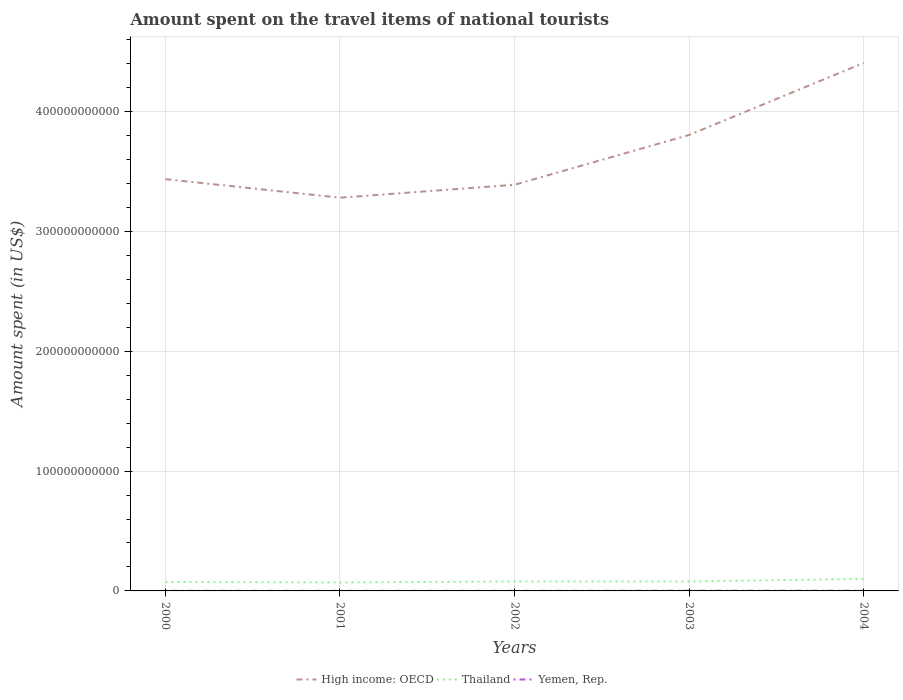How many different coloured lines are there?
Provide a short and direct response. 3. Is the number of lines equal to the number of legend labels?
Offer a terse response. Yes. Across all years, what is the maximum amount spent on the travel items of national tourists in Thailand?
Offer a terse response. 7.08e+09. What is the total amount spent on the travel items of national tourists in High income: OECD in the graph?
Your answer should be compact. -1.08e+1. What is the difference between the highest and the second highest amount spent on the travel items of national tourists in Thailand?
Your answer should be very brief. 2.97e+09. What is the difference between the highest and the lowest amount spent on the travel items of national tourists in Yemen, Rep.?
Keep it short and to the point. 2. Is the amount spent on the travel items of national tourists in Thailand strictly greater than the amount spent on the travel items of national tourists in Yemen, Rep. over the years?
Offer a terse response. No. How many years are there in the graph?
Keep it short and to the point. 5. What is the difference between two consecutive major ticks on the Y-axis?
Provide a short and direct response. 1.00e+11. Are the values on the major ticks of Y-axis written in scientific E-notation?
Your answer should be compact. No. Does the graph contain grids?
Your answer should be compact. Yes. Where does the legend appear in the graph?
Ensure brevity in your answer.  Bottom center. How are the legend labels stacked?
Ensure brevity in your answer.  Horizontal. What is the title of the graph?
Make the answer very short. Amount spent on the travel items of national tourists. What is the label or title of the X-axis?
Offer a terse response. Years. What is the label or title of the Y-axis?
Give a very brief answer. Amount spent (in US$). What is the Amount spent (in US$) in High income: OECD in 2000?
Provide a short and direct response. 3.44e+11. What is the Amount spent (in US$) of Thailand in 2000?
Your response must be concise. 7.48e+09. What is the Amount spent (in US$) in Yemen, Rep. in 2000?
Offer a terse response. 7.30e+07. What is the Amount spent (in US$) of High income: OECD in 2001?
Offer a very short reply. 3.28e+11. What is the Amount spent (in US$) in Thailand in 2001?
Make the answer very short. 7.08e+09. What is the Amount spent (in US$) of Yemen, Rep. in 2001?
Provide a short and direct response. 3.80e+07. What is the Amount spent (in US$) of High income: OECD in 2002?
Provide a short and direct response. 3.39e+11. What is the Amount spent (in US$) in Thailand in 2002?
Offer a very short reply. 7.90e+09. What is the Amount spent (in US$) of Yemen, Rep. in 2002?
Offer a terse response. 3.80e+07. What is the Amount spent (in US$) in High income: OECD in 2003?
Offer a terse response. 3.80e+11. What is the Amount spent (in US$) in Thailand in 2003?
Keep it short and to the point. 7.86e+09. What is the Amount spent (in US$) in Yemen, Rep. in 2003?
Ensure brevity in your answer.  1.39e+08. What is the Amount spent (in US$) of High income: OECD in 2004?
Offer a very short reply. 4.40e+11. What is the Amount spent (in US$) in Thailand in 2004?
Offer a terse response. 1.00e+1. What is the Amount spent (in US$) in Yemen, Rep. in 2004?
Provide a short and direct response. 1.39e+08. Across all years, what is the maximum Amount spent (in US$) of High income: OECD?
Keep it short and to the point. 4.40e+11. Across all years, what is the maximum Amount spent (in US$) in Thailand?
Give a very brief answer. 1.00e+1. Across all years, what is the maximum Amount spent (in US$) of Yemen, Rep.?
Offer a very short reply. 1.39e+08. Across all years, what is the minimum Amount spent (in US$) in High income: OECD?
Give a very brief answer. 3.28e+11. Across all years, what is the minimum Amount spent (in US$) of Thailand?
Your answer should be compact. 7.08e+09. Across all years, what is the minimum Amount spent (in US$) of Yemen, Rep.?
Ensure brevity in your answer.  3.80e+07. What is the total Amount spent (in US$) in High income: OECD in the graph?
Give a very brief answer. 1.83e+12. What is the total Amount spent (in US$) in Thailand in the graph?
Offer a very short reply. 4.04e+1. What is the total Amount spent (in US$) in Yemen, Rep. in the graph?
Keep it short and to the point. 4.27e+08. What is the difference between the Amount spent (in US$) in High income: OECD in 2000 and that in 2001?
Your answer should be very brief. 1.55e+1. What is the difference between the Amount spent (in US$) of Thailand in 2000 and that in 2001?
Give a very brief answer. 4.08e+08. What is the difference between the Amount spent (in US$) in Yemen, Rep. in 2000 and that in 2001?
Keep it short and to the point. 3.50e+07. What is the difference between the Amount spent (in US$) in High income: OECD in 2000 and that in 2002?
Make the answer very short. 4.70e+09. What is the difference between the Amount spent (in US$) of Thailand in 2000 and that in 2002?
Ensure brevity in your answer.  -4.18e+08. What is the difference between the Amount spent (in US$) in Yemen, Rep. in 2000 and that in 2002?
Provide a succinct answer. 3.50e+07. What is the difference between the Amount spent (in US$) of High income: OECD in 2000 and that in 2003?
Your response must be concise. -3.68e+1. What is the difference between the Amount spent (in US$) in Thailand in 2000 and that in 2003?
Your answer should be very brief. -3.73e+08. What is the difference between the Amount spent (in US$) of Yemen, Rep. in 2000 and that in 2003?
Provide a short and direct response. -6.60e+07. What is the difference between the Amount spent (in US$) of High income: OECD in 2000 and that in 2004?
Offer a very short reply. -9.69e+1. What is the difference between the Amount spent (in US$) of Thailand in 2000 and that in 2004?
Give a very brief answer. -2.56e+09. What is the difference between the Amount spent (in US$) of Yemen, Rep. in 2000 and that in 2004?
Offer a terse response. -6.60e+07. What is the difference between the Amount spent (in US$) of High income: OECD in 2001 and that in 2002?
Ensure brevity in your answer.  -1.08e+1. What is the difference between the Amount spent (in US$) in Thailand in 2001 and that in 2002?
Provide a succinct answer. -8.26e+08. What is the difference between the Amount spent (in US$) of Yemen, Rep. in 2001 and that in 2002?
Offer a very short reply. 0. What is the difference between the Amount spent (in US$) of High income: OECD in 2001 and that in 2003?
Provide a succinct answer. -5.23e+1. What is the difference between the Amount spent (in US$) of Thailand in 2001 and that in 2003?
Make the answer very short. -7.81e+08. What is the difference between the Amount spent (in US$) in Yemen, Rep. in 2001 and that in 2003?
Your answer should be compact. -1.01e+08. What is the difference between the Amount spent (in US$) of High income: OECD in 2001 and that in 2004?
Ensure brevity in your answer.  -1.12e+11. What is the difference between the Amount spent (in US$) of Thailand in 2001 and that in 2004?
Keep it short and to the point. -2.97e+09. What is the difference between the Amount spent (in US$) in Yemen, Rep. in 2001 and that in 2004?
Give a very brief answer. -1.01e+08. What is the difference between the Amount spent (in US$) of High income: OECD in 2002 and that in 2003?
Offer a very short reply. -4.15e+1. What is the difference between the Amount spent (in US$) of Thailand in 2002 and that in 2003?
Give a very brief answer. 4.50e+07. What is the difference between the Amount spent (in US$) of Yemen, Rep. in 2002 and that in 2003?
Provide a short and direct response. -1.01e+08. What is the difference between the Amount spent (in US$) of High income: OECD in 2002 and that in 2004?
Offer a terse response. -1.02e+11. What is the difference between the Amount spent (in US$) in Thailand in 2002 and that in 2004?
Offer a very short reply. -2.14e+09. What is the difference between the Amount spent (in US$) in Yemen, Rep. in 2002 and that in 2004?
Make the answer very short. -1.01e+08. What is the difference between the Amount spent (in US$) in High income: OECD in 2003 and that in 2004?
Provide a short and direct response. -6.01e+1. What is the difference between the Amount spent (in US$) in Thailand in 2003 and that in 2004?
Your answer should be very brief. -2.19e+09. What is the difference between the Amount spent (in US$) in High income: OECD in 2000 and the Amount spent (in US$) in Thailand in 2001?
Keep it short and to the point. 3.36e+11. What is the difference between the Amount spent (in US$) of High income: OECD in 2000 and the Amount spent (in US$) of Yemen, Rep. in 2001?
Your answer should be very brief. 3.43e+11. What is the difference between the Amount spent (in US$) in Thailand in 2000 and the Amount spent (in US$) in Yemen, Rep. in 2001?
Your answer should be very brief. 7.44e+09. What is the difference between the Amount spent (in US$) of High income: OECD in 2000 and the Amount spent (in US$) of Thailand in 2002?
Provide a short and direct response. 3.36e+11. What is the difference between the Amount spent (in US$) in High income: OECD in 2000 and the Amount spent (in US$) in Yemen, Rep. in 2002?
Ensure brevity in your answer.  3.43e+11. What is the difference between the Amount spent (in US$) in Thailand in 2000 and the Amount spent (in US$) in Yemen, Rep. in 2002?
Offer a terse response. 7.44e+09. What is the difference between the Amount spent (in US$) of High income: OECD in 2000 and the Amount spent (in US$) of Thailand in 2003?
Give a very brief answer. 3.36e+11. What is the difference between the Amount spent (in US$) of High income: OECD in 2000 and the Amount spent (in US$) of Yemen, Rep. in 2003?
Your response must be concise. 3.43e+11. What is the difference between the Amount spent (in US$) in Thailand in 2000 and the Amount spent (in US$) in Yemen, Rep. in 2003?
Your answer should be compact. 7.34e+09. What is the difference between the Amount spent (in US$) of High income: OECD in 2000 and the Amount spent (in US$) of Thailand in 2004?
Ensure brevity in your answer.  3.33e+11. What is the difference between the Amount spent (in US$) of High income: OECD in 2000 and the Amount spent (in US$) of Yemen, Rep. in 2004?
Provide a short and direct response. 3.43e+11. What is the difference between the Amount spent (in US$) of Thailand in 2000 and the Amount spent (in US$) of Yemen, Rep. in 2004?
Keep it short and to the point. 7.34e+09. What is the difference between the Amount spent (in US$) of High income: OECD in 2001 and the Amount spent (in US$) of Thailand in 2002?
Ensure brevity in your answer.  3.20e+11. What is the difference between the Amount spent (in US$) of High income: OECD in 2001 and the Amount spent (in US$) of Yemen, Rep. in 2002?
Make the answer very short. 3.28e+11. What is the difference between the Amount spent (in US$) of Thailand in 2001 and the Amount spent (in US$) of Yemen, Rep. in 2002?
Give a very brief answer. 7.04e+09. What is the difference between the Amount spent (in US$) in High income: OECD in 2001 and the Amount spent (in US$) in Thailand in 2003?
Provide a succinct answer. 3.20e+11. What is the difference between the Amount spent (in US$) in High income: OECD in 2001 and the Amount spent (in US$) in Yemen, Rep. in 2003?
Offer a very short reply. 3.28e+11. What is the difference between the Amount spent (in US$) of Thailand in 2001 and the Amount spent (in US$) of Yemen, Rep. in 2003?
Your answer should be compact. 6.94e+09. What is the difference between the Amount spent (in US$) in High income: OECD in 2001 and the Amount spent (in US$) in Thailand in 2004?
Give a very brief answer. 3.18e+11. What is the difference between the Amount spent (in US$) of High income: OECD in 2001 and the Amount spent (in US$) of Yemen, Rep. in 2004?
Ensure brevity in your answer.  3.28e+11. What is the difference between the Amount spent (in US$) in Thailand in 2001 and the Amount spent (in US$) in Yemen, Rep. in 2004?
Offer a terse response. 6.94e+09. What is the difference between the Amount spent (in US$) of High income: OECD in 2002 and the Amount spent (in US$) of Thailand in 2003?
Offer a terse response. 3.31e+11. What is the difference between the Amount spent (in US$) in High income: OECD in 2002 and the Amount spent (in US$) in Yemen, Rep. in 2003?
Give a very brief answer. 3.39e+11. What is the difference between the Amount spent (in US$) of Thailand in 2002 and the Amount spent (in US$) of Yemen, Rep. in 2003?
Offer a very short reply. 7.76e+09. What is the difference between the Amount spent (in US$) in High income: OECD in 2002 and the Amount spent (in US$) in Thailand in 2004?
Keep it short and to the point. 3.29e+11. What is the difference between the Amount spent (in US$) of High income: OECD in 2002 and the Amount spent (in US$) of Yemen, Rep. in 2004?
Your response must be concise. 3.39e+11. What is the difference between the Amount spent (in US$) in Thailand in 2002 and the Amount spent (in US$) in Yemen, Rep. in 2004?
Keep it short and to the point. 7.76e+09. What is the difference between the Amount spent (in US$) of High income: OECD in 2003 and the Amount spent (in US$) of Thailand in 2004?
Ensure brevity in your answer.  3.70e+11. What is the difference between the Amount spent (in US$) in High income: OECD in 2003 and the Amount spent (in US$) in Yemen, Rep. in 2004?
Offer a very short reply. 3.80e+11. What is the difference between the Amount spent (in US$) in Thailand in 2003 and the Amount spent (in US$) in Yemen, Rep. in 2004?
Give a very brief answer. 7.72e+09. What is the average Amount spent (in US$) in High income: OECD per year?
Offer a very short reply. 3.66e+11. What is the average Amount spent (in US$) in Thailand per year?
Provide a succinct answer. 8.07e+09. What is the average Amount spent (in US$) of Yemen, Rep. per year?
Ensure brevity in your answer.  8.54e+07. In the year 2000, what is the difference between the Amount spent (in US$) of High income: OECD and Amount spent (in US$) of Thailand?
Ensure brevity in your answer.  3.36e+11. In the year 2000, what is the difference between the Amount spent (in US$) of High income: OECD and Amount spent (in US$) of Yemen, Rep.?
Offer a very short reply. 3.43e+11. In the year 2000, what is the difference between the Amount spent (in US$) in Thailand and Amount spent (in US$) in Yemen, Rep.?
Your response must be concise. 7.41e+09. In the year 2001, what is the difference between the Amount spent (in US$) of High income: OECD and Amount spent (in US$) of Thailand?
Offer a very short reply. 3.21e+11. In the year 2001, what is the difference between the Amount spent (in US$) of High income: OECD and Amount spent (in US$) of Yemen, Rep.?
Offer a terse response. 3.28e+11. In the year 2001, what is the difference between the Amount spent (in US$) of Thailand and Amount spent (in US$) of Yemen, Rep.?
Keep it short and to the point. 7.04e+09. In the year 2002, what is the difference between the Amount spent (in US$) of High income: OECD and Amount spent (in US$) of Thailand?
Your response must be concise. 3.31e+11. In the year 2002, what is the difference between the Amount spent (in US$) of High income: OECD and Amount spent (in US$) of Yemen, Rep.?
Provide a succinct answer. 3.39e+11. In the year 2002, what is the difference between the Amount spent (in US$) of Thailand and Amount spent (in US$) of Yemen, Rep.?
Ensure brevity in your answer.  7.86e+09. In the year 2003, what is the difference between the Amount spent (in US$) of High income: OECD and Amount spent (in US$) of Thailand?
Keep it short and to the point. 3.73e+11. In the year 2003, what is the difference between the Amount spent (in US$) in High income: OECD and Amount spent (in US$) in Yemen, Rep.?
Ensure brevity in your answer.  3.80e+11. In the year 2003, what is the difference between the Amount spent (in US$) in Thailand and Amount spent (in US$) in Yemen, Rep.?
Your response must be concise. 7.72e+09. In the year 2004, what is the difference between the Amount spent (in US$) of High income: OECD and Amount spent (in US$) of Thailand?
Your response must be concise. 4.30e+11. In the year 2004, what is the difference between the Amount spent (in US$) of High income: OECD and Amount spent (in US$) of Yemen, Rep.?
Offer a very short reply. 4.40e+11. In the year 2004, what is the difference between the Amount spent (in US$) in Thailand and Amount spent (in US$) in Yemen, Rep.?
Give a very brief answer. 9.90e+09. What is the ratio of the Amount spent (in US$) of High income: OECD in 2000 to that in 2001?
Offer a very short reply. 1.05. What is the ratio of the Amount spent (in US$) in Thailand in 2000 to that in 2001?
Your response must be concise. 1.06. What is the ratio of the Amount spent (in US$) in Yemen, Rep. in 2000 to that in 2001?
Your answer should be very brief. 1.92. What is the ratio of the Amount spent (in US$) of High income: OECD in 2000 to that in 2002?
Give a very brief answer. 1.01. What is the ratio of the Amount spent (in US$) in Thailand in 2000 to that in 2002?
Offer a very short reply. 0.95. What is the ratio of the Amount spent (in US$) in Yemen, Rep. in 2000 to that in 2002?
Offer a terse response. 1.92. What is the ratio of the Amount spent (in US$) of High income: OECD in 2000 to that in 2003?
Provide a short and direct response. 0.9. What is the ratio of the Amount spent (in US$) in Thailand in 2000 to that in 2003?
Ensure brevity in your answer.  0.95. What is the ratio of the Amount spent (in US$) in Yemen, Rep. in 2000 to that in 2003?
Offer a terse response. 0.53. What is the ratio of the Amount spent (in US$) of High income: OECD in 2000 to that in 2004?
Provide a short and direct response. 0.78. What is the ratio of the Amount spent (in US$) of Thailand in 2000 to that in 2004?
Offer a very short reply. 0.75. What is the ratio of the Amount spent (in US$) of Yemen, Rep. in 2000 to that in 2004?
Offer a very short reply. 0.53. What is the ratio of the Amount spent (in US$) in High income: OECD in 2001 to that in 2002?
Offer a very short reply. 0.97. What is the ratio of the Amount spent (in US$) in Thailand in 2001 to that in 2002?
Your answer should be compact. 0.9. What is the ratio of the Amount spent (in US$) of Yemen, Rep. in 2001 to that in 2002?
Your response must be concise. 1. What is the ratio of the Amount spent (in US$) in High income: OECD in 2001 to that in 2003?
Your answer should be very brief. 0.86. What is the ratio of the Amount spent (in US$) in Thailand in 2001 to that in 2003?
Ensure brevity in your answer.  0.9. What is the ratio of the Amount spent (in US$) in Yemen, Rep. in 2001 to that in 2003?
Your response must be concise. 0.27. What is the ratio of the Amount spent (in US$) of High income: OECD in 2001 to that in 2004?
Ensure brevity in your answer.  0.74. What is the ratio of the Amount spent (in US$) of Thailand in 2001 to that in 2004?
Provide a succinct answer. 0.7. What is the ratio of the Amount spent (in US$) in Yemen, Rep. in 2001 to that in 2004?
Keep it short and to the point. 0.27. What is the ratio of the Amount spent (in US$) in High income: OECD in 2002 to that in 2003?
Offer a very short reply. 0.89. What is the ratio of the Amount spent (in US$) of Thailand in 2002 to that in 2003?
Offer a terse response. 1.01. What is the ratio of the Amount spent (in US$) in Yemen, Rep. in 2002 to that in 2003?
Provide a short and direct response. 0.27. What is the ratio of the Amount spent (in US$) in High income: OECD in 2002 to that in 2004?
Make the answer very short. 0.77. What is the ratio of the Amount spent (in US$) of Thailand in 2002 to that in 2004?
Provide a succinct answer. 0.79. What is the ratio of the Amount spent (in US$) of Yemen, Rep. in 2002 to that in 2004?
Your answer should be very brief. 0.27. What is the ratio of the Amount spent (in US$) in High income: OECD in 2003 to that in 2004?
Provide a succinct answer. 0.86. What is the ratio of the Amount spent (in US$) in Thailand in 2003 to that in 2004?
Offer a terse response. 0.78. What is the ratio of the Amount spent (in US$) in Yemen, Rep. in 2003 to that in 2004?
Provide a succinct answer. 1. What is the difference between the highest and the second highest Amount spent (in US$) of High income: OECD?
Ensure brevity in your answer.  6.01e+1. What is the difference between the highest and the second highest Amount spent (in US$) in Thailand?
Make the answer very short. 2.14e+09. What is the difference between the highest and the lowest Amount spent (in US$) in High income: OECD?
Make the answer very short. 1.12e+11. What is the difference between the highest and the lowest Amount spent (in US$) of Thailand?
Provide a succinct answer. 2.97e+09. What is the difference between the highest and the lowest Amount spent (in US$) in Yemen, Rep.?
Offer a very short reply. 1.01e+08. 